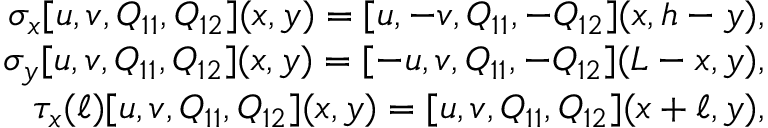Convert formula to latex. <formula><loc_0><loc_0><loc_500><loc_500>\begin{array} { r } { \sigma _ { x } [ u , v , Q _ { 1 1 } , Q _ { 1 2 } ] ( x , y ) = [ u , - v , Q _ { 1 1 } , - Q _ { 1 2 } ] ( x , h - y ) , } \\ { \sigma _ { y } [ u , v , Q _ { 1 1 } , Q _ { 1 2 } ] ( x , y ) = [ - u , v , Q _ { 1 1 } , - Q _ { 1 2 } ] ( L - x , y ) , } \\ { \tau _ { x } ( \ell ) [ u , v , Q _ { 1 1 } , Q _ { 1 2 } ] ( x , y ) = [ u , v , Q _ { 1 1 } , Q _ { 1 2 } ] ( x + \ell , y ) , } \end{array}</formula> 